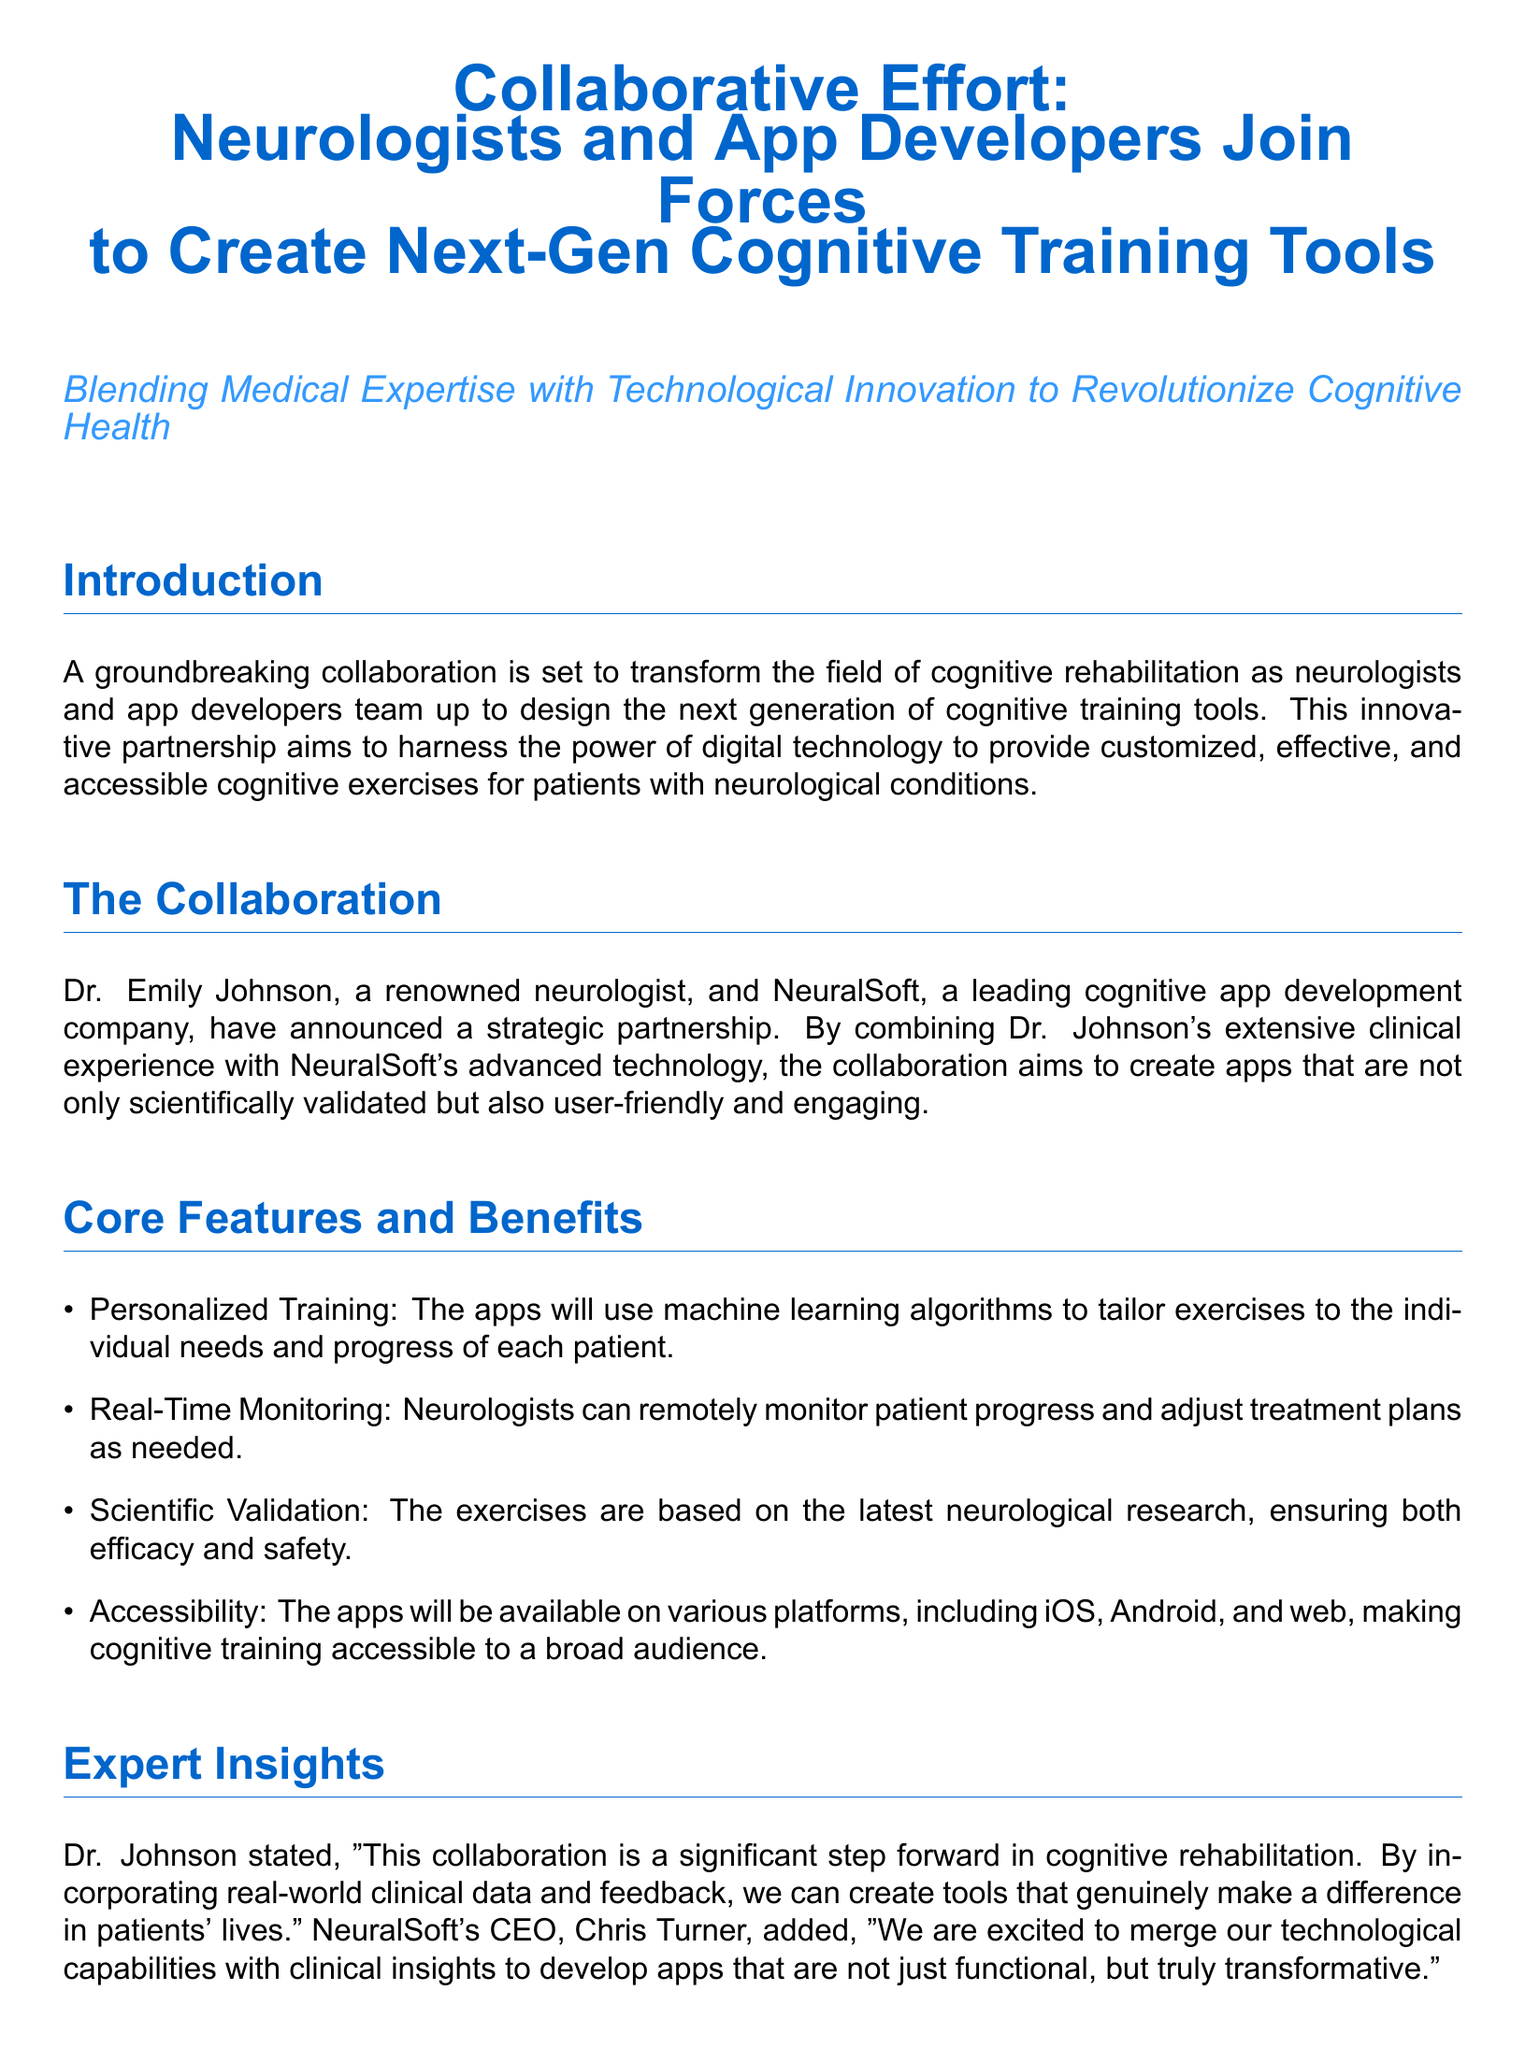What is the name of the neurologist involved in the collaboration? The document identifies Dr. Emily Johnson as the neurologist collaborating with NeuralSoft.
Answer: Dr. Emily Johnson What company is partnering with Dr. Johnson? The partnering company mentioned in the document is NeuralSoft.
Answer: NeuralSoft What primary feature allows for personalized training in the apps? The apps will use machine learning algorithms to tailor exercises to individual needs.
Answer: Machine learning algorithms What percentage improvement in cognitive function was observed in initial trials? The trials at the Neurological Institute reported a 20% improvement in cognitive function.
Answer: 20% What technology integration does the partnership plan for future apps? The collaboration aims to integrate virtual reality and augmented reality in the apps.
Answer: Virtual reality and augmented reality Who is the CEO of NeuralSoft? The document states that Chris Turner is the CEO of NeuralSoft.
Answer: Chris Turner What is one of the enhancements planned for the apps based on user feedback? There are plans to refine and enhance the apps continually based on ongoing research and user feedback.
Answer: Refine and enhance the apps What type of document is this? The document is a press release describing a collaboration.
Answer: Press release 